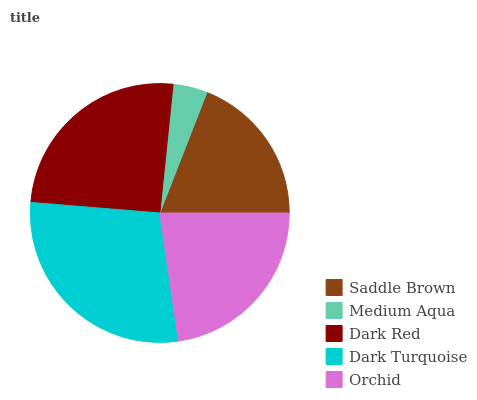Is Medium Aqua the minimum?
Answer yes or no. Yes. Is Dark Turquoise the maximum?
Answer yes or no. Yes. Is Dark Red the minimum?
Answer yes or no. No. Is Dark Red the maximum?
Answer yes or no. No. Is Dark Red greater than Medium Aqua?
Answer yes or no. Yes. Is Medium Aqua less than Dark Red?
Answer yes or no. Yes. Is Medium Aqua greater than Dark Red?
Answer yes or no. No. Is Dark Red less than Medium Aqua?
Answer yes or no. No. Is Orchid the high median?
Answer yes or no. Yes. Is Orchid the low median?
Answer yes or no. Yes. Is Dark Turquoise the high median?
Answer yes or no. No. Is Dark Turquoise the low median?
Answer yes or no. No. 